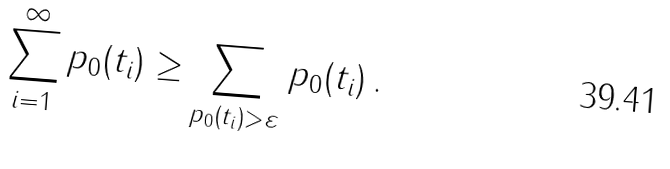<formula> <loc_0><loc_0><loc_500><loc_500>\sum _ { i = 1 } ^ { \infty } p _ { 0 } ( t _ { i } ) \geq \sum _ { p _ { 0 } ( t _ { i } ) > \varepsilon } p _ { 0 } ( t _ { i } ) \, .</formula> 